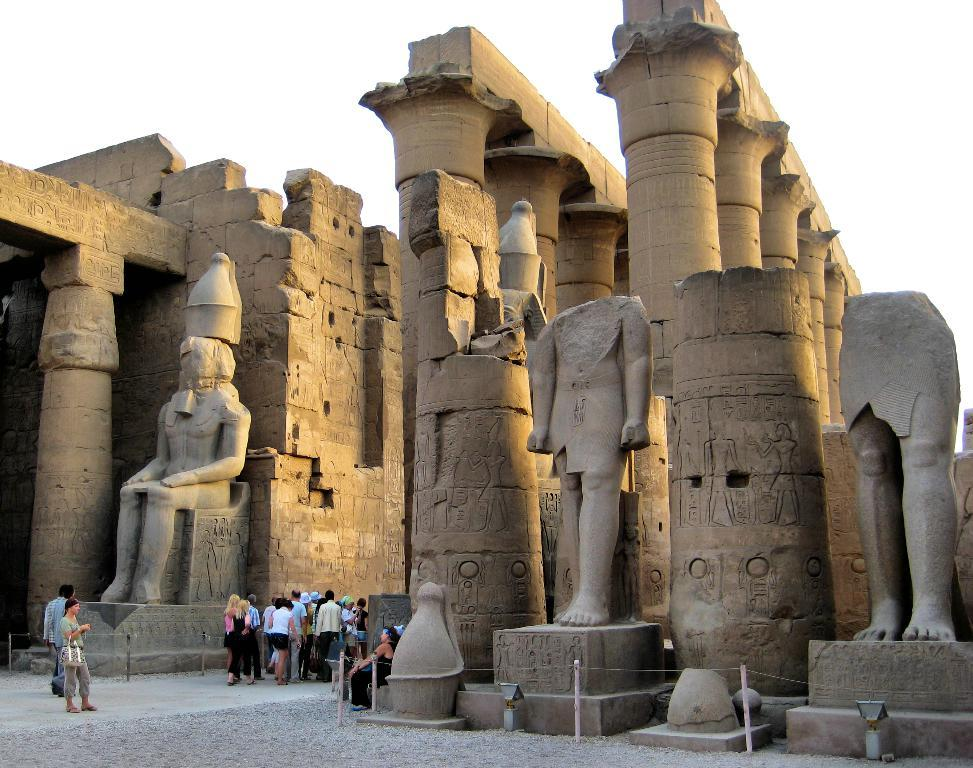Who is present in the image? There are people in the image. What are the people doing in the image? The people are visiting an archaeological site. What can be found at the archaeological site? There are statues and pillars at the archaeological site. What type of plastic material can be seen at the archaeological site? There is no plastic material present at the archaeological site in the image. What is the connection between the people and the statues in the image? The image does not show any direct connection between the people and the statues; they are simply visiting the archaeological site. 